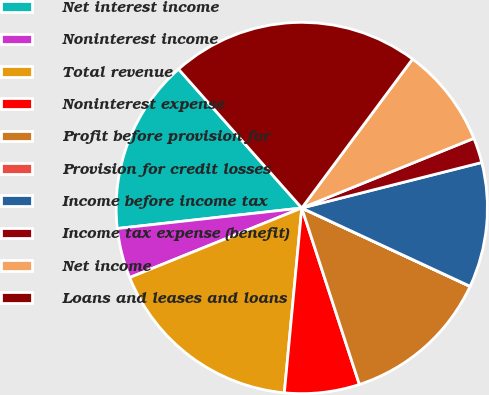Convert chart to OTSL. <chart><loc_0><loc_0><loc_500><loc_500><pie_chart><fcel>Net interest income<fcel>Noninterest income<fcel>Total revenue<fcel>Noninterest expense<fcel>Profit before provision for<fcel>Provision for credit losses<fcel>Income before income tax<fcel>Income tax expense (benefit)<fcel>Net income<fcel>Loans and leases and loans<nl><fcel>15.21%<fcel>4.35%<fcel>17.39%<fcel>6.52%<fcel>13.04%<fcel>0.01%<fcel>10.87%<fcel>2.18%<fcel>8.7%<fcel>21.73%<nl></chart> 